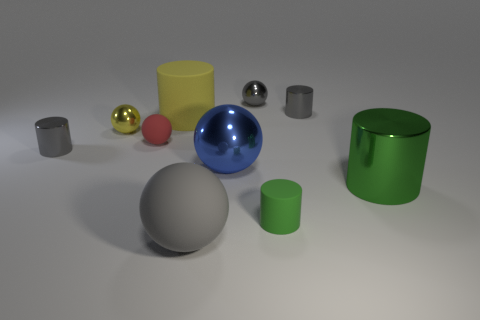There is a green metal thing that is right of the yellow sphere; what is its size?
Provide a succinct answer. Large. What material is the ball that is the same size as the blue object?
Provide a succinct answer. Rubber. Is the shape of the big green thing the same as the green rubber object?
Offer a very short reply. Yes. What number of objects are either blue objects or cylinders that are in front of the small yellow thing?
Offer a very short reply. 4. There is another cylinder that is the same color as the tiny rubber cylinder; what is its material?
Provide a short and direct response. Metal. Does the matte sphere that is to the left of the yellow rubber cylinder have the same size as the green metallic object?
Your answer should be compact. No. There is a small cylinder that is on the left side of the tiny rubber thing that is to the left of the large yellow matte thing; how many tiny cylinders are behind it?
Ensure brevity in your answer.  1. What number of blue things are either small rubber objects or large rubber things?
Offer a terse response. 0. What is the color of the big cylinder that is made of the same material as the small red thing?
Give a very brief answer. Yellow. How many large objects are either cylinders or rubber balls?
Give a very brief answer. 3. 